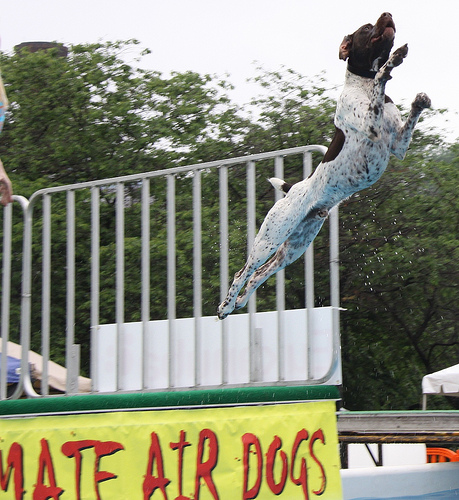<image>
Is there a dog on the fence? No. The dog is not positioned on the fence. They may be near each other, but the dog is not supported by or resting on top of the fence. Is there a fence under the dog? No. The fence is not positioned under the dog. The vertical relationship between these objects is different. Is the dog above the sign? No. The dog is not positioned above the sign. The vertical arrangement shows a different relationship. 